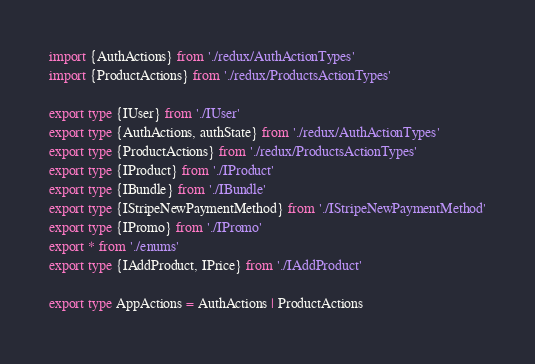<code> <loc_0><loc_0><loc_500><loc_500><_TypeScript_>import {AuthActions} from './redux/AuthActionTypes'
import {ProductActions} from './redux/ProductsActionTypes'

export type {IUser} from './IUser'
export type {AuthActions, authState} from './redux/AuthActionTypes'
export type {ProductActions} from './redux/ProductsActionTypes'
export type {IProduct} from './IProduct'
export type {IBundle} from './IBundle'
export type {IStripeNewPaymentMethod} from './IStripeNewPaymentMethod'
export type {IPromo} from './IPromo'
export * from './enums'
export type {IAddProduct, IPrice} from './IAddProduct'

export type AppActions = AuthActions | ProductActions
</code> 